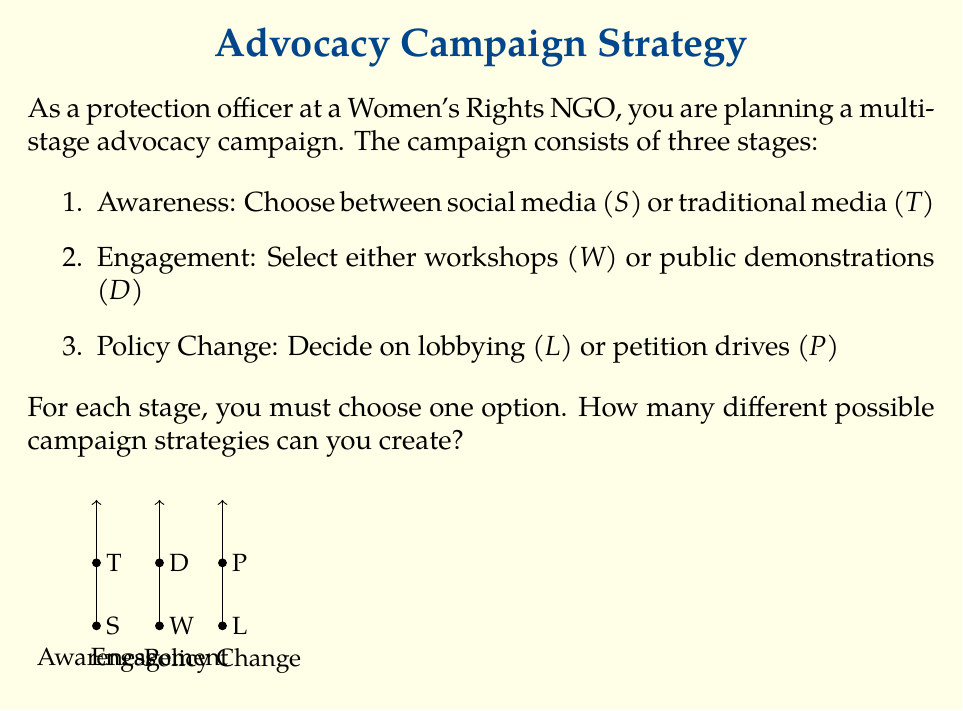Provide a solution to this math problem. To solve this problem, we'll use the multiplication principle of counting. This principle states that if we have a sequence of independent choices, the total number of outcomes is the product of the number of options for each choice.

Let's break it down step-by-step:

1. For the Awareness stage:
   - We have 2 options: social media ($S$) or traditional media ($T$)
   - Number of choices for this stage = 2

2. For the Engagement stage:
   - We have 2 options: workshops ($W$) or public demonstrations ($D$)
   - Number of choices for this stage = 2

3. For the Policy Change stage:
   - We have 2 options: lobbying ($L$) or petition drives ($P$)
   - Number of choices for this stage = 2

Now, to find the total number of possible campaign strategies, we multiply the number of choices for each stage:

$$\text{Total strategies} = 2 \times 2 \times 2 = 2^3 = 8$$

This means there are 8 different possible campaign strategies. We can list them out to verify:

1. $S-W-L$
2. $S-W-P$
3. $S-D-L$
4. $S-D-P$
5. $T-W-L$
6. $T-W-P$
7. $T-D-L$
8. $T-D-P$

Each of these represents a unique combination of choices for the three stages of the advocacy campaign.
Answer: 8 strategies 